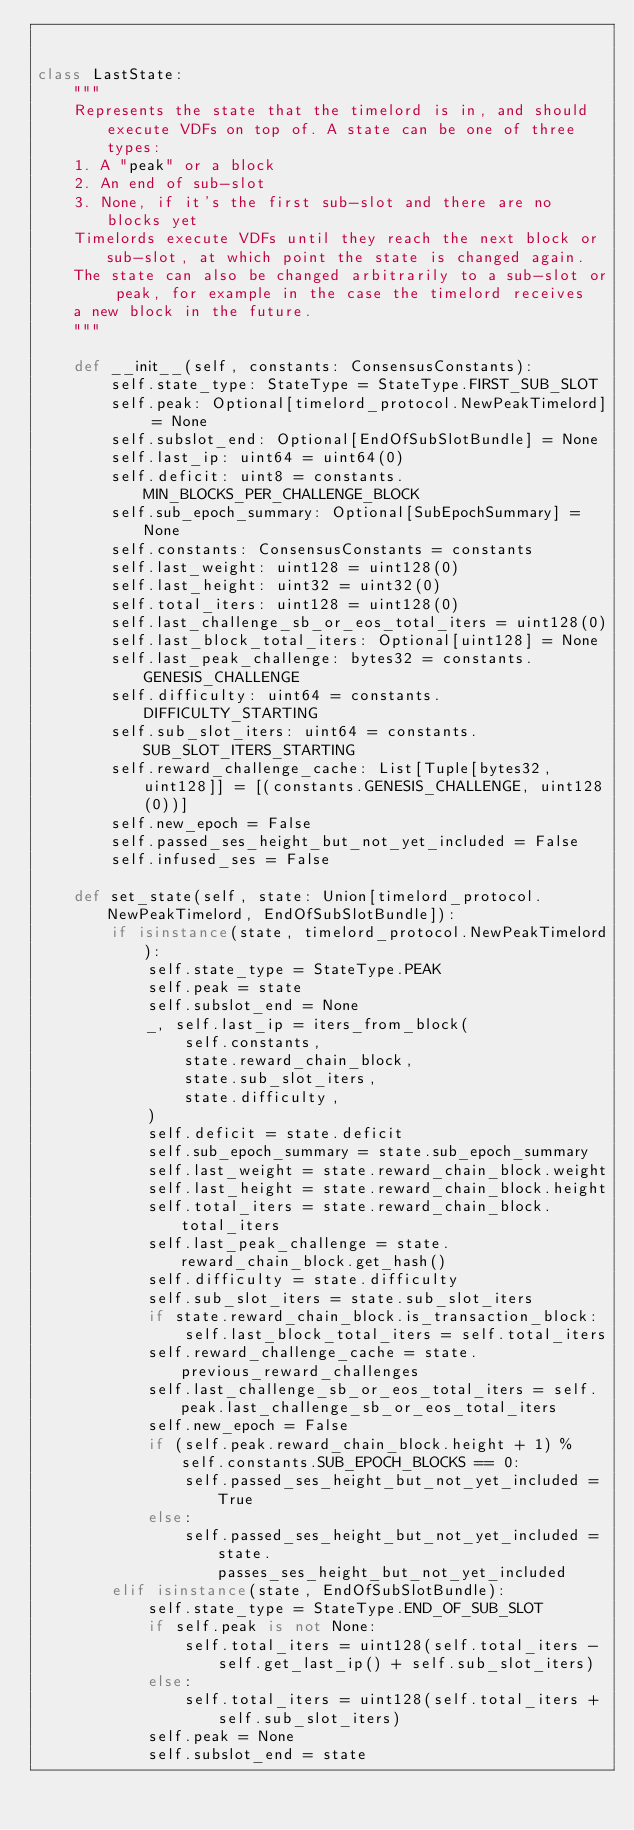<code> <loc_0><loc_0><loc_500><loc_500><_Python_>

class LastState:
    """
    Represents the state that the timelord is in, and should execute VDFs on top of. A state can be one of three types:
    1. A "peak" or a block
    2. An end of sub-slot
    3. None, if it's the first sub-slot and there are no blocks yet
    Timelords execute VDFs until they reach the next block or sub-slot, at which point the state is changed again.
    The state can also be changed arbitrarily to a sub-slot or peak, for example in the case the timelord receives
    a new block in the future.
    """

    def __init__(self, constants: ConsensusConstants):
        self.state_type: StateType = StateType.FIRST_SUB_SLOT
        self.peak: Optional[timelord_protocol.NewPeakTimelord] = None
        self.subslot_end: Optional[EndOfSubSlotBundle] = None
        self.last_ip: uint64 = uint64(0)
        self.deficit: uint8 = constants.MIN_BLOCKS_PER_CHALLENGE_BLOCK
        self.sub_epoch_summary: Optional[SubEpochSummary] = None
        self.constants: ConsensusConstants = constants
        self.last_weight: uint128 = uint128(0)
        self.last_height: uint32 = uint32(0)
        self.total_iters: uint128 = uint128(0)
        self.last_challenge_sb_or_eos_total_iters = uint128(0)
        self.last_block_total_iters: Optional[uint128] = None
        self.last_peak_challenge: bytes32 = constants.GENESIS_CHALLENGE
        self.difficulty: uint64 = constants.DIFFICULTY_STARTING
        self.sub_slot_iters: uint64 = constants.SUB_SLOT_ITERS_STARTING
        self.reward_challenge_cache: List[Tuple[bytes32, uint128]] = [(constants.GENESIS_CHALLENGE, uint128(0))]
        self.new_epoch = False
        self.passed_ses_height_but_not_yet_included = False
        self.infused_ses = False

    def set_state(self, state: Union[timelord_protocol.NewPeakTimelord, EndOfSubSlotBundle]):
        if isinstance(state, timelord_protocol.NewPeakTimelord):
            self.state_type = StateType.PEAK
            self.peak = state
            self.subslot_end = None
            _, self.last_ip = iters_from_block(
                self.constants,
                state.reward_chain_block,
                state.sub_slot_iters,
                state.difficulty,
            )
            self.deficit = state.deficit
            self.sub_epoch_summary = state.sub_epoch_summary
            self.last_weight = state.reward_chain_block.weight
            self.last_height = state.reward_chain_block.height
            self.total_iters = state.reward_chain_block.total_iters
            self.last_peak_challenge = state.reward_chain_block.get_hash()
            self.difficulty = state.difficulty
            self.sub_slot_iters = state.sub_slot_iters
            if state.reward_chain_block.is_transaction_block:
                self.last_block_total_iters = self.total_iters
            self.reward_challenge_cache = state.previous_reward_challenges
            self.last_challenge_sb_or_eos_total_iters = self.peak.last_challenge_sb_or_eos_total_iters
            self.new_epoch = False
            if (self.peak.reward_chain_block.height + 1) % self.constants.SUB_EPOCH_BLOCKS == 0:
                self.passed_ses_height_but_not_yet_included = True
            else:
                self.passed_ses_height_but_not_yet_included = state.passes_ses_height_but_not_yet_included
        elif isinstance(state, EndOfSubSlotBundle):
            self.state_type = StateType.END_OF_SUB_SLOT
            if self.peak is not None:
                self.total_iters = uint128(self.total_iters - self.get_last_ip() + self.sub_slot_iters)
            else:
                self.total_iters = uint128(self.total_iters + self.sub_slot_iters)
            self.peak = None
            self.subslot_end = state</code> 